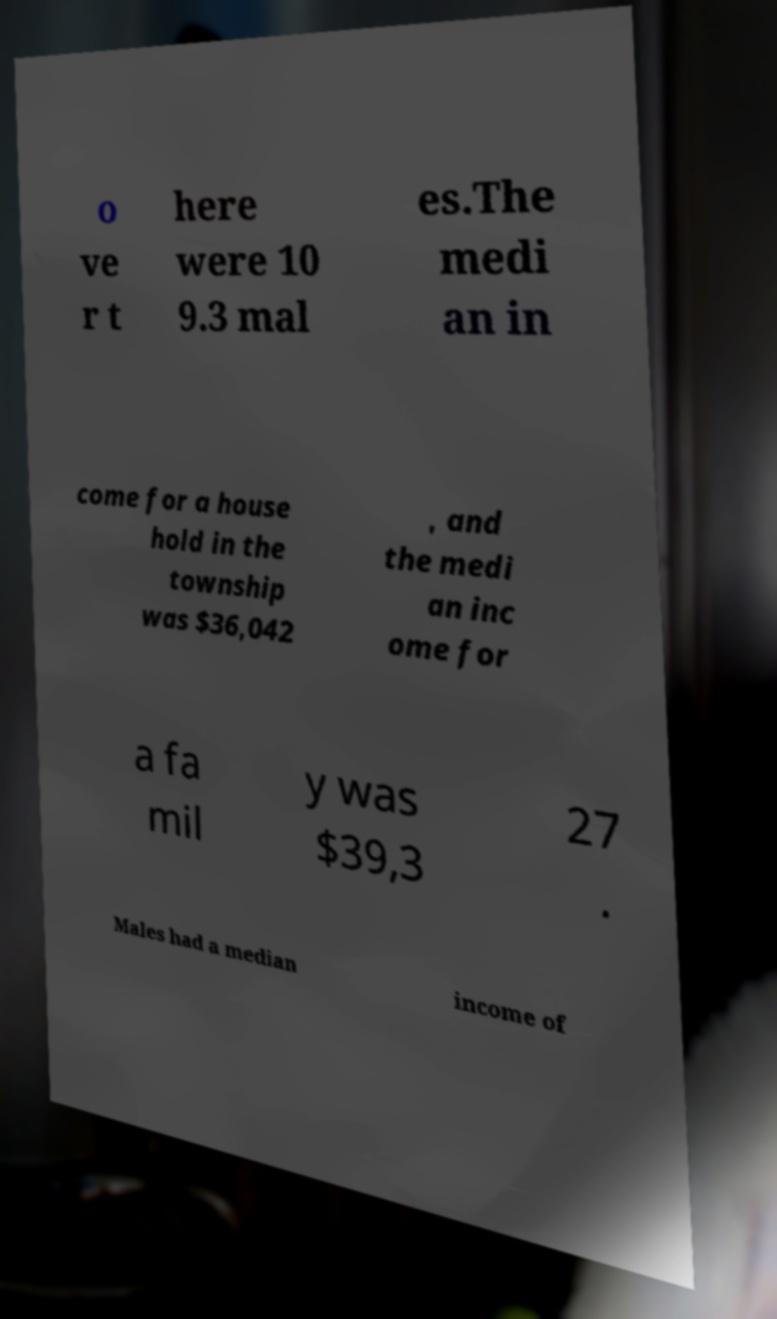Can you accurately transcribe the text from the provided image for me? o ve r t here were 10 9.3 mal es.The medi an in come for a house hold in the township was $36,042 , and the medi an inc ome for a fa mil y was $39,3 27 . Males had a median income of 